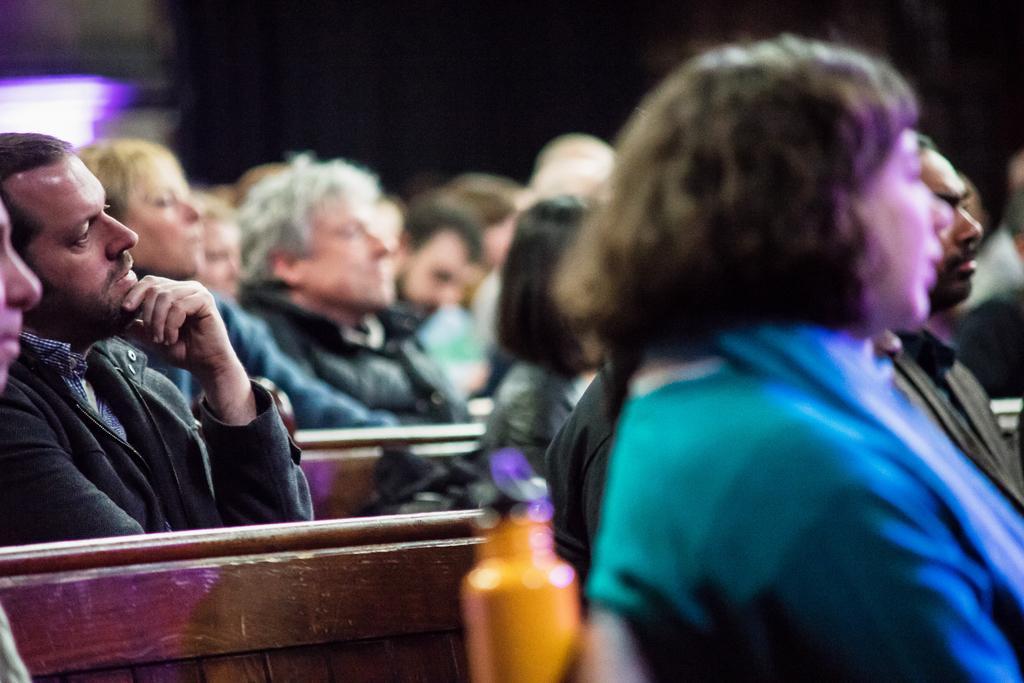Can you describe this image briefly? In the picture we can see some people are sitting on the benches and listening to something and one person is holding a bottle which is yellow in color and behind we can see dark. 